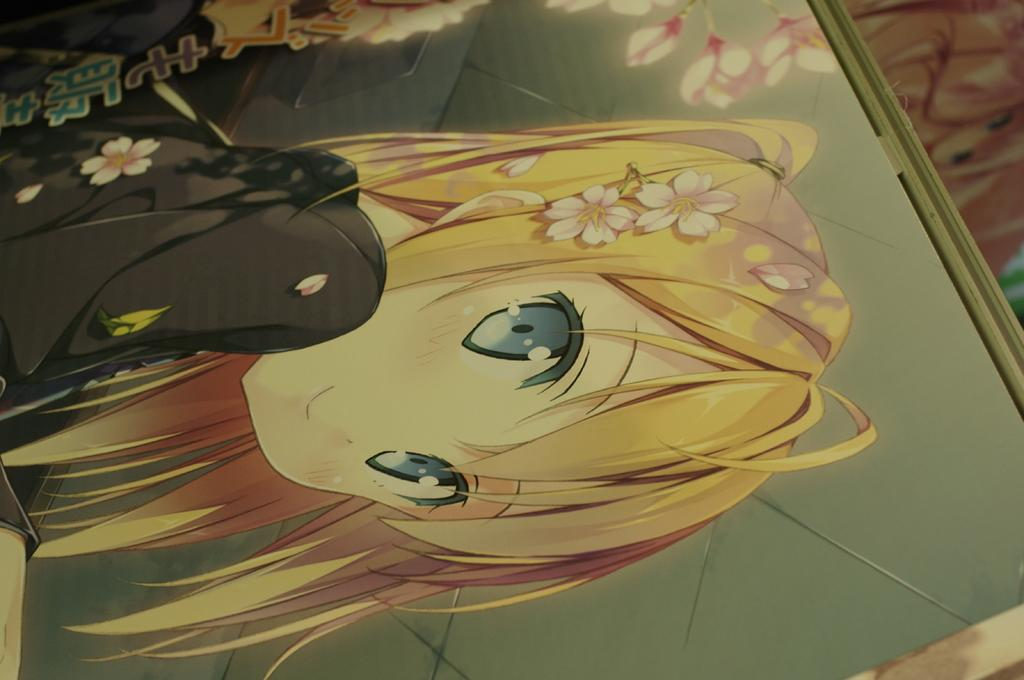What type of image is depicted in the picture? There is an animated picture of a woman in the image. What else can be seen in the image besides the animated woman? There is text and flowers in the image. What is the background object in the image? There is a board in the image. Where is the basket located in the image? There is no basket present in the image. What type of playground equipment can be seen in the image? There is no playground equipment present in the image. 